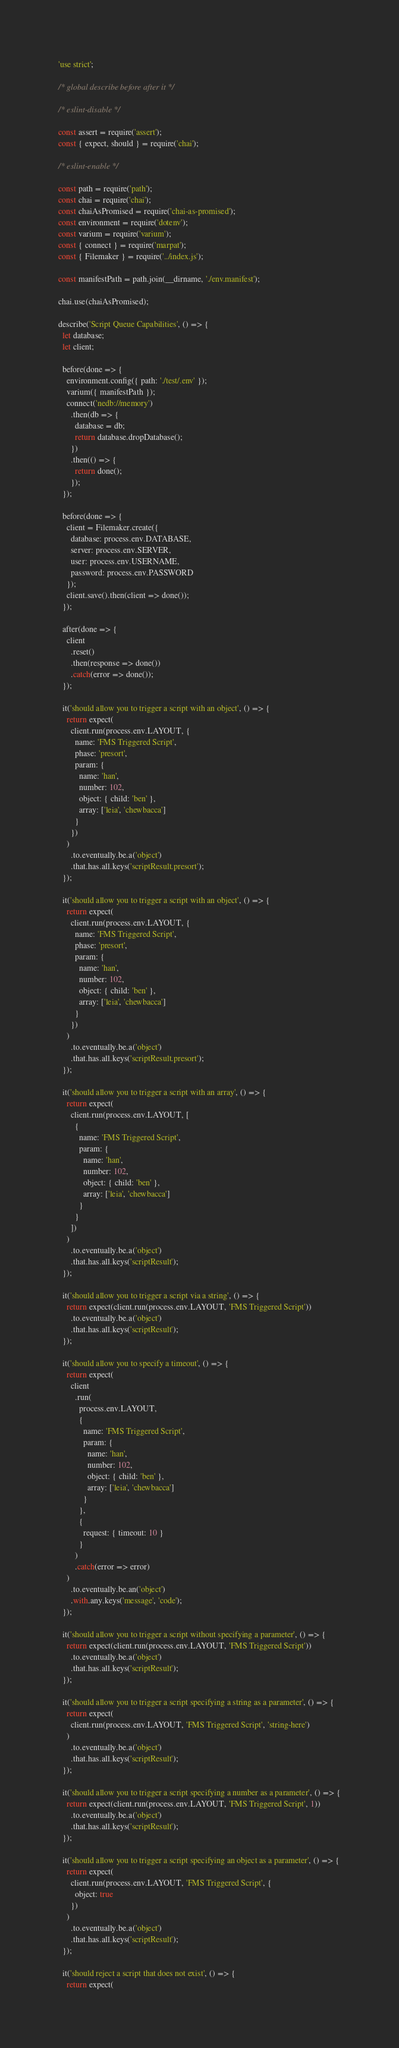Convert code to text. <code><loc_0><loc_0><loc_500><loc_500><_JavaScript_>'use strict';

/* global describe before after it */

/* eslint-disable */

const assert = require('assert');
const { expect, should } = require('chai');

/* eslint-enable */

const path = require('path');
const chai = require('chai');
const chaiAsPromised = require('chai-as-promised');
const environment = require('dotenv');
const varium = require('varium');
const { connect } = require('marpat');
const { Filemaker } = require('../index.js');

const manifestPath = path.join(__dirname, './env.manifest');

chai.use(chaiAsPromised);

describe('Script Queue Capabilities', () => {
  let database;
  let client;

  before(done => {
    environment.config({ path: './test/.env' });
    varium({ manifestPath });
    connect('nedb://memory')
      .then(db => {
        database = db;
        return database.dropDatabase();
      })
      .then(() => {
        return done();
      });
  });

  before(done => {
    client = Filemaker.create({
      database: process.env.DATABASE,
      server: process.env.SERVER,
      user: process.env.USERNAME,
      password: process.env.PASSWORD
    });
    client.save().then(client => done());
  });

  after(done => {
    client
      .reset()
      .then(response => done())
      .catch(error => done());
  });

  it('should allow you to trigger a script with an object', () => {
    return expect(
      client.run(process.env.LAYOUT, {
        name: 'FMS Triggered Script',
        phase: 'presort',
        param: {
          name: 'han',
          number: 102,
          object: { child: 'ben' },
          array: ['leia', 'chewbacca']
        }
      })
    )
      .to.eventually.be.a('object')
      .that.has.all.keys('scriptResult.presort');
  });

  it('should allow you to trigger a script with an object', () => {
    return expect(
      client.run(process.env.LAYOUT, {
        name: 'FMS Triggered Script',
        phase: 'presort',
        param: {
          name: 'han',
          number: 102,
          object: { child: 'ben' },
          array: ['leia', 'chewbacca']
        }
      })
    )
      .to.eventually.be.a('object')
      .that.has.all.keys('scriptResult.presort');
  });

  it('should allow you to trigger a script with an array', () => {
    return expect(
      client.run(process.env.LAYOUT, [
        {
          name: 'FMS Triggered Script',
          param: {
            name: 'han',
            number: 102,
            object: { child: 'ben' },
            array: ['leia', 'chewbacca']
          }
        }
      ])
    )
      .to.eventually.be.a('object')
      .that.has.all.keys('scriptResult');
  });

  it('should allow you to trigger a script via a string', () => {
    return expect(client.run(process.env.LAYOUT, 'FMS Triggered Script'))
      .to.eventually.be.a('object')
      .that.has.all.keys('scriptResult');
  });

  it('should allow you to specify a timeout', () => {
    return expect(
      client
        .run(
          process.env.LAYOUT,
          {
            name: 'FMS Triggered Script',
            param: {
              name: 'han',
              number: 102,
              object: { child: 'ben' },
              array: ['leia', 'chewbacca']
            }
          },
          {
            request: { timeout: 10 }
          }
        )
        .catch(error => error)
    )
      .to.eventually.be.an('object')
      .with.any.keys('message', 'code');
  });

  it('should allow you to trigger a script without specifying a parameter', () => {
    return expect(client.run(process.env.LAYOUT, 'FMS Triggered Script'))
      .to.eventually.be.a('object')
      .that.has.all.keys('scriptResult');
  });

  it('should allow you to trigger a script specifying a string as a parameter', () => {
    return expect(
      client.run(process.env.LAYOUT, 'FMS Triggered Script', 'string-here')
    )
      .to.eventually.be.a('object')
      .that.has.all.keys('scriptResult');
  });

  it('should allow you to trigger a script specifying a number as a parameter', () => {
    return expect(client.run(process.env.LAYOUT, 'FMS Triggered Script', 1))
      .to.eventually.be.a('object')
      .that.has.all.keys('scriptResult');
  });

  it('should allow you to trigger a script specifying an object as a parameter', () => {
    return expect(
      client.run(process.env.LAYOUT, 'FMS Triggered Script', {
        object: true
      })
    )
      .to.eventually.be.a('object')
      .that.has.all.keys('scriptResult');
  });

  it('should reject a script that does not exist', () => {
    return expect(</code> 